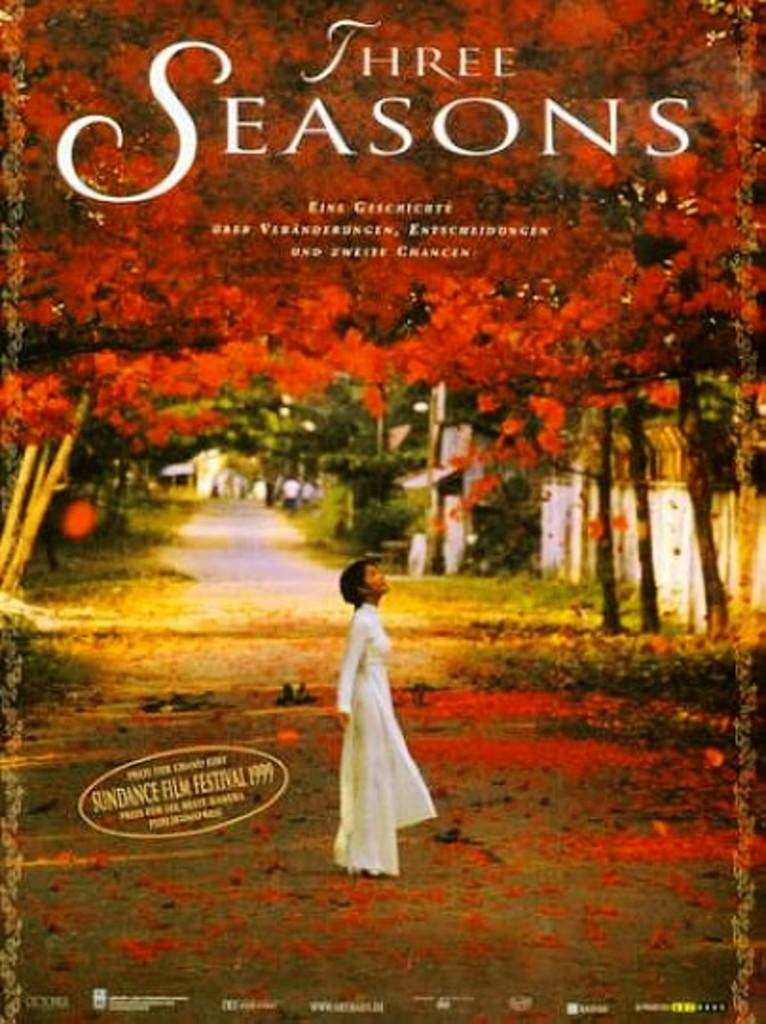<image>
Present a compact description of the photo's key features. A movie cover with the title Three Seasons. 